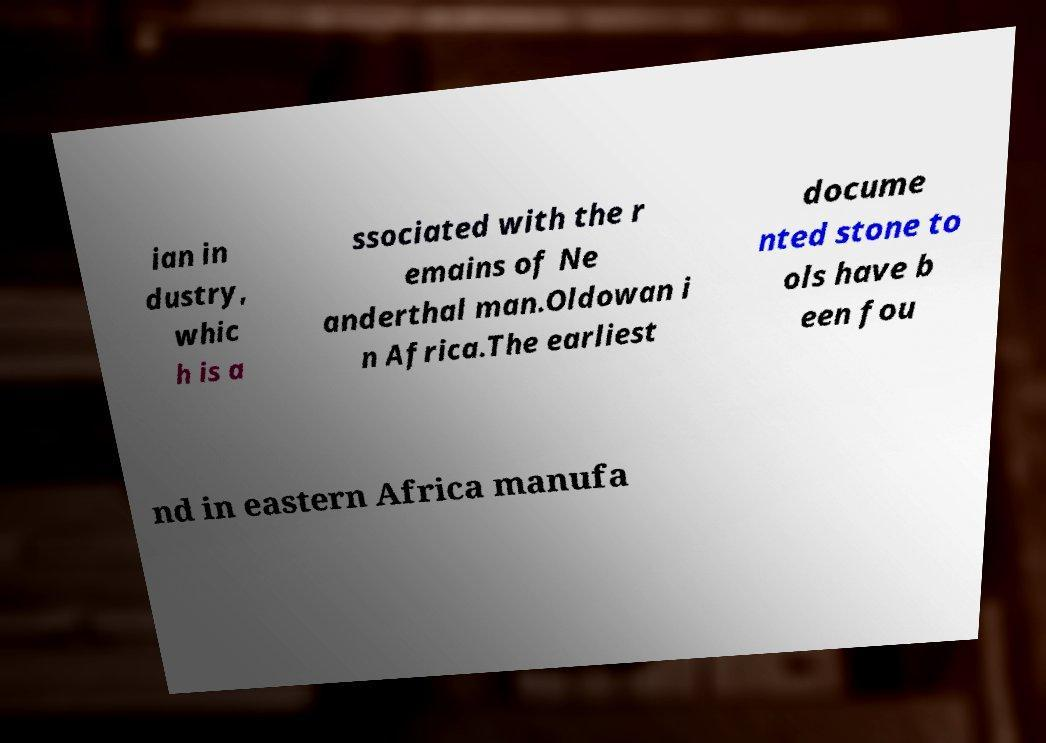Can you accurately transcribe the text from the provided image for me? ian in dustry, whic h is a ssociated with the r emains of Ne anderthal man.Oldowan i n Africa.The earliest docume nted stone to ols have b een fou nd in eastern Africa manufa 